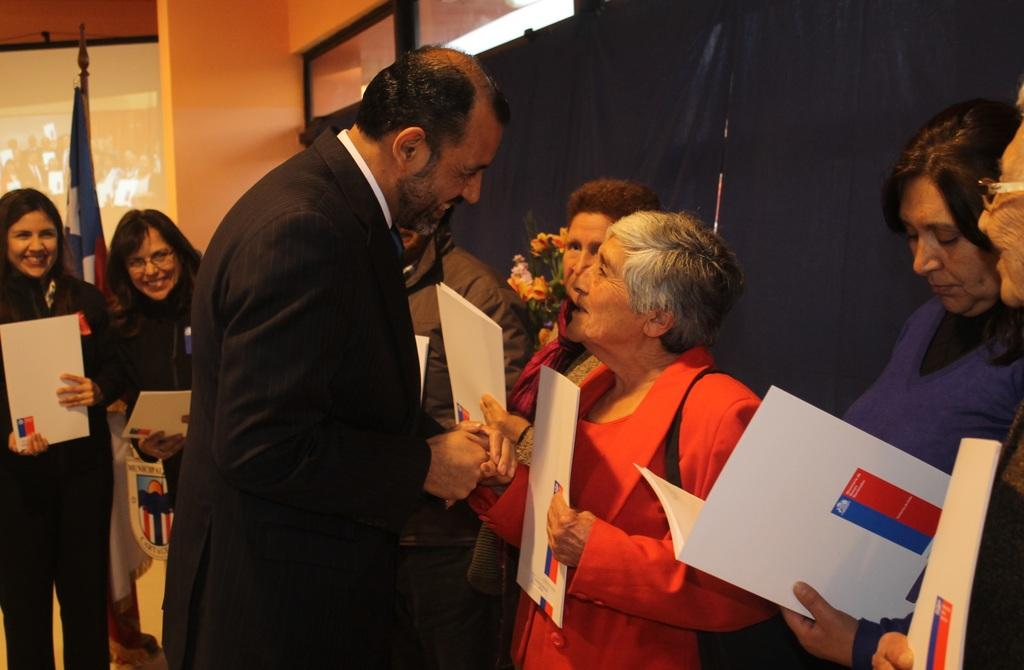What is happening with the group of people in the image? The people in the image are standing and holding files. What can be seen in the background of the image? There is a flag, glass doors, and a screen in the background of the image. How does the spark from the screen affect the people in the image? There is no spark from the screen in the image, so it does not affect the people. What type of bridge is visible in the image? There is no bridge present in the image. 